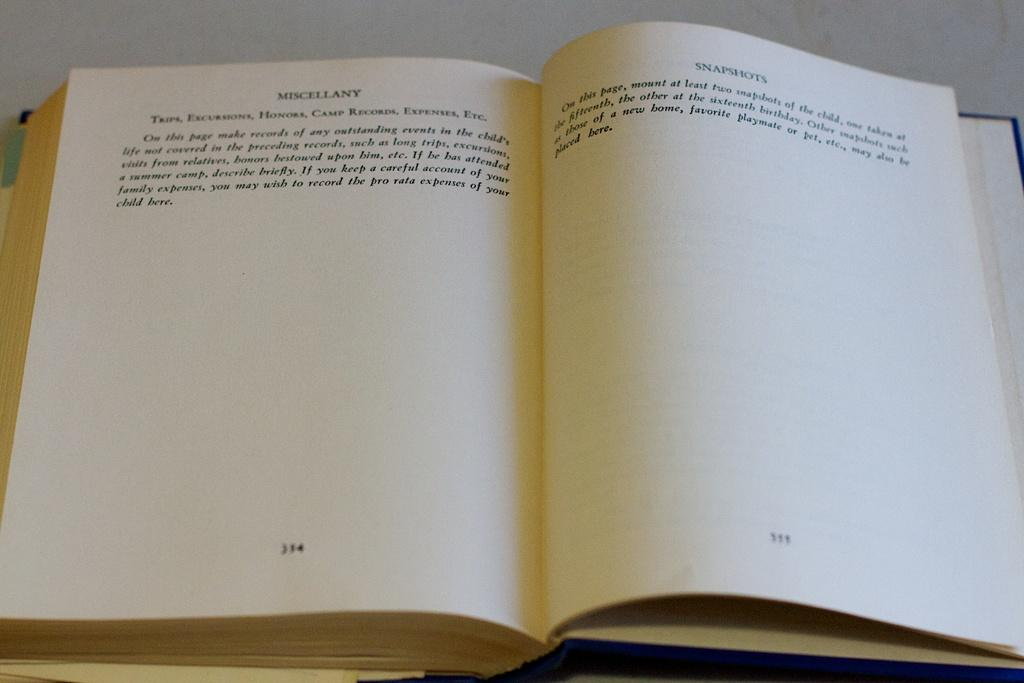<image>
Write a terse but informative summary of the picture. The second page from this book starts with Snapshots. 